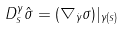<formula> <loc_0><loc_0><loc_500><loc_500>D ^ { \gamma } _ { s } \hat { \sigma } = ( \nabla _ { \dot { \gamma } } \sigma ) | _ { \gamma ( s ) }</formula> 